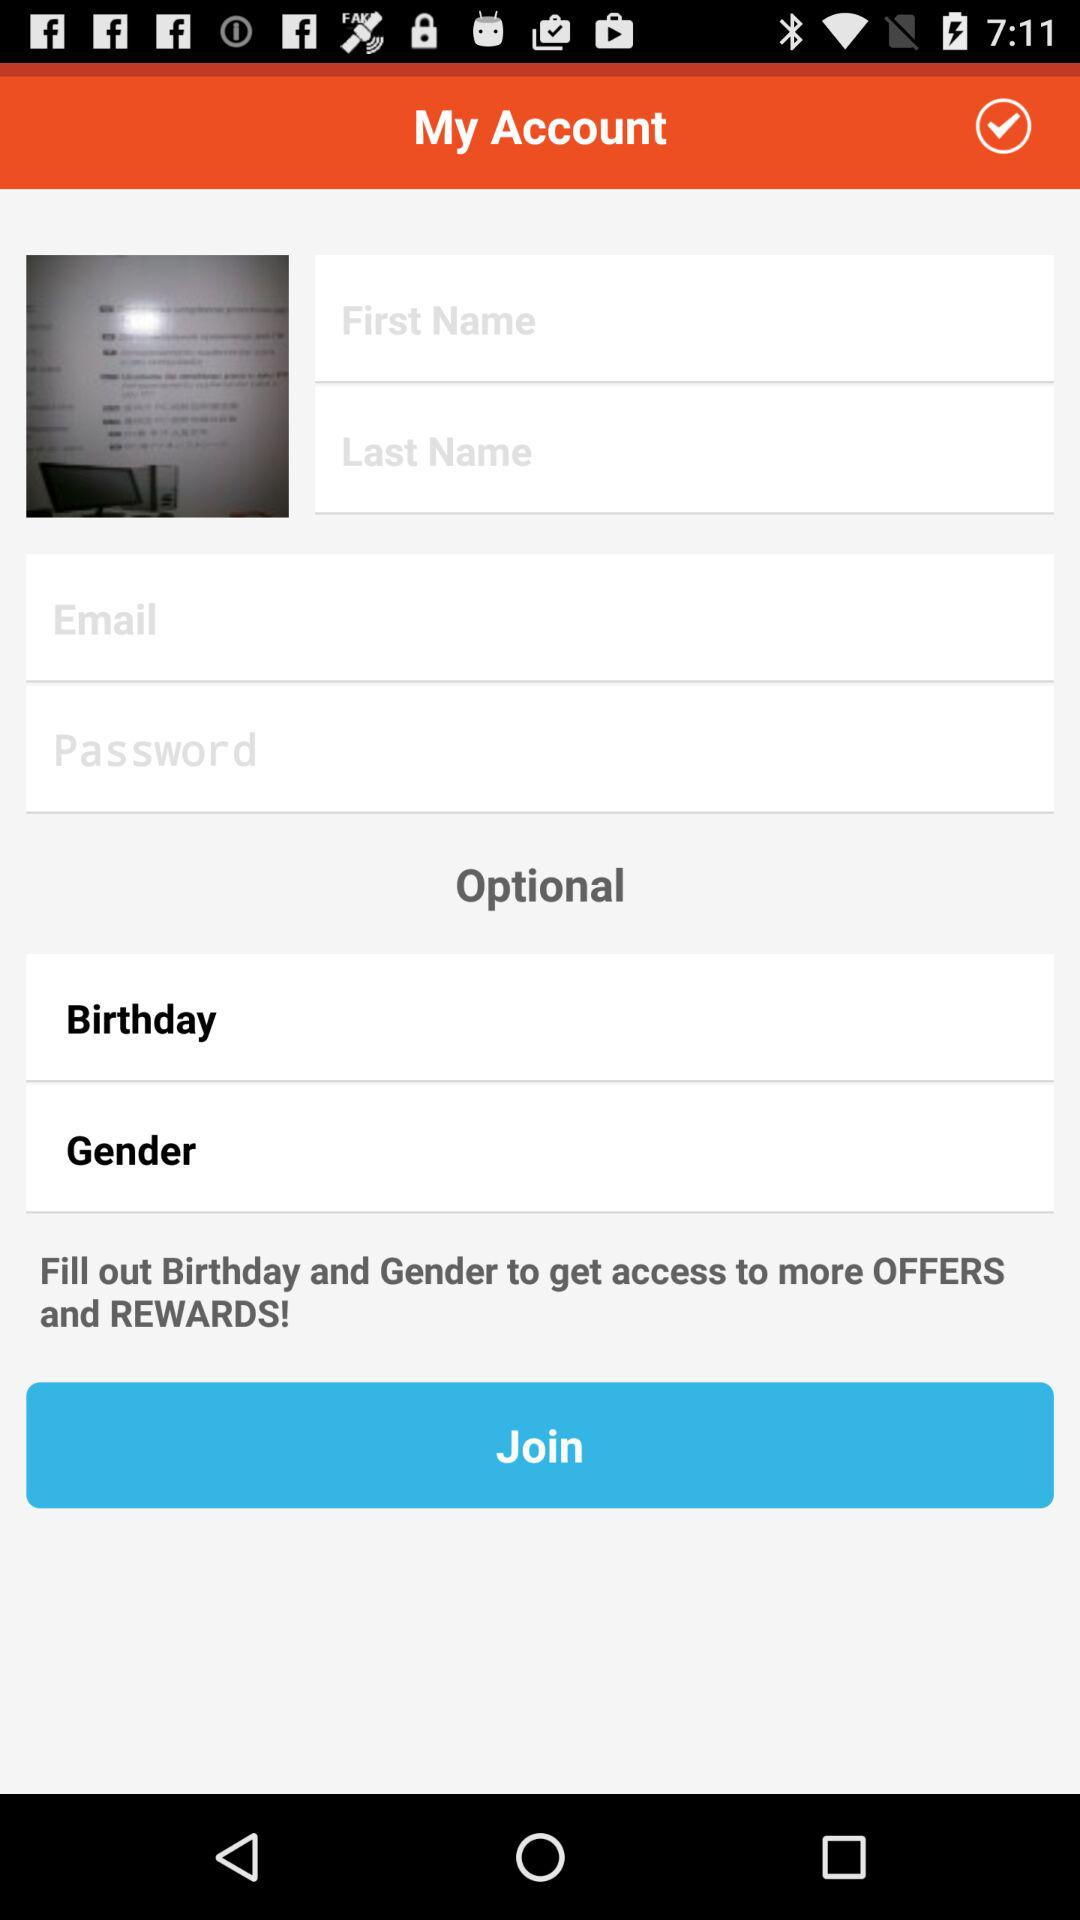What is required to fill in to get access to more offers and rewards? To get access to more offers and rewards, fill in your birthday and gender. 